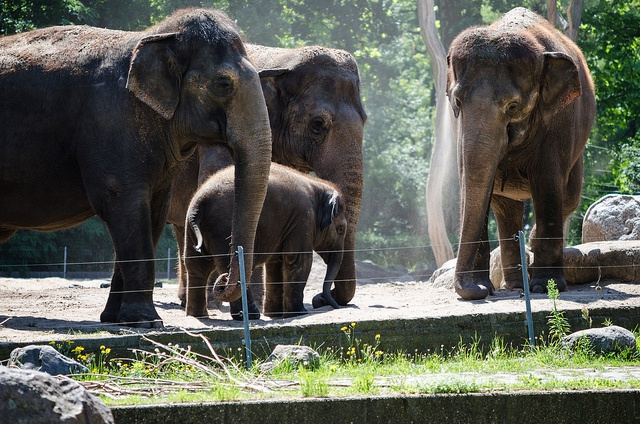Describe the objects in this image and their specific colors. I can see elephant in black, gray, and darkgray tones, elephant in black, gray, and maroon tones, elephant in black, gray, darkgray, and lightgray tones, and elephant in black, gray, and lightgray tones in this image. 